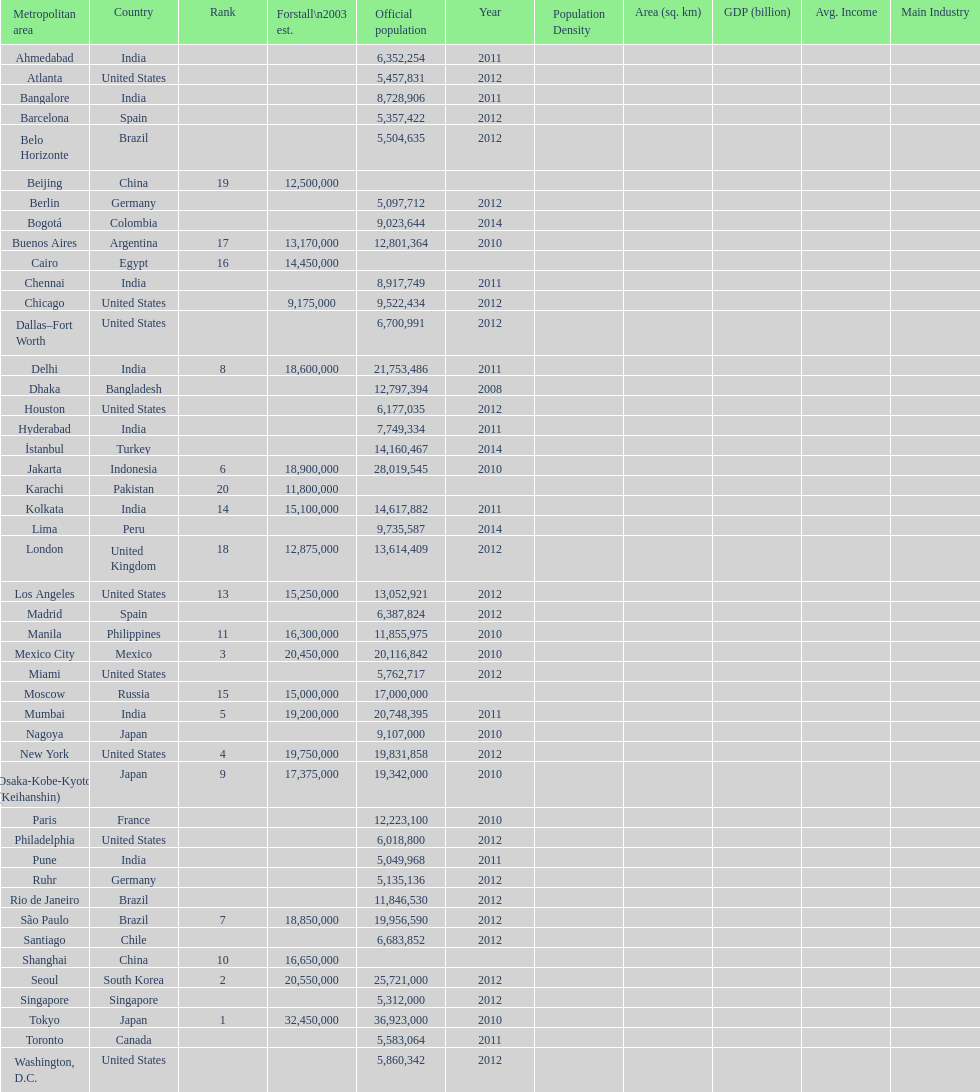Name a city from the same country as bangalore. Ahmedabad. 